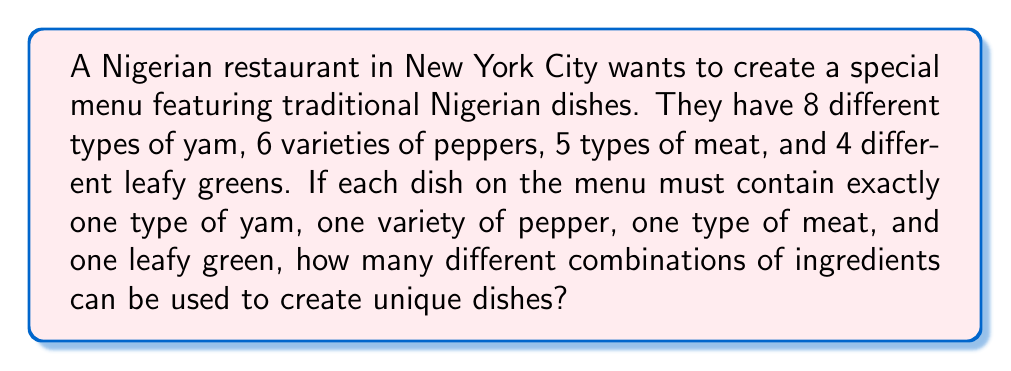Can you answer this question? To solve this problem, we'll use the multiplication principle of counting. Since we need to choose one item from each category, and the choices are independent of each other, we multiply the number of options for each category:

1. Number of yam options: 8
2. Number of pepper varieties: 6
3. Number of meat types: 5
4. Number of leafy green options: 4

The total number of combinations is:

$$ 8 \times 6 \times 5 \times 4 $$

Let's calculate this step by step:

$$ 8 \times 6 = 48 $$
$$ 48 \times 5 = 240 $$
$$ 240 \times 4 = 960 $$

Therefore, the restaurant can create 960 unique combinations of traditional Nigerian dishes using these ingredients.
Answer: 960 